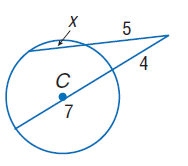Answer the mathemtical geometry problem and directly provide the correct option letter.
Question: Find x. Assume that segments that appear to be tangent are tangent.
Choices: A: 3.8 B: 4 C: 5 D: 7 A 